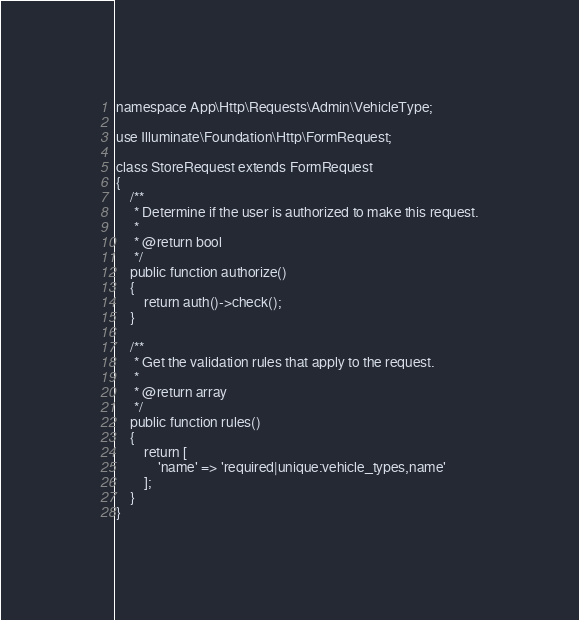<code> <loc_0><loc_0><loc_500><loc_500><_PHP_>namespace App\Http\Requests\Admin\VehicleType;

use Illuminate\Foundation\Http\FormRequest;

class StoreRequest extends FormRequest
{
    /**
     * Determine if the user is authorized to make this request.
     *
     * @return bool
     */
    public function authorize()
    {
        return auth()->check();
    }

    /**
     * Get the validation rules that apply to the request.
     *
     * @return array
     */
    public function rules()
    {
        return [
            'name' => 'required|unique:vehicle_types,name'
        ];
    }
}
</code> 